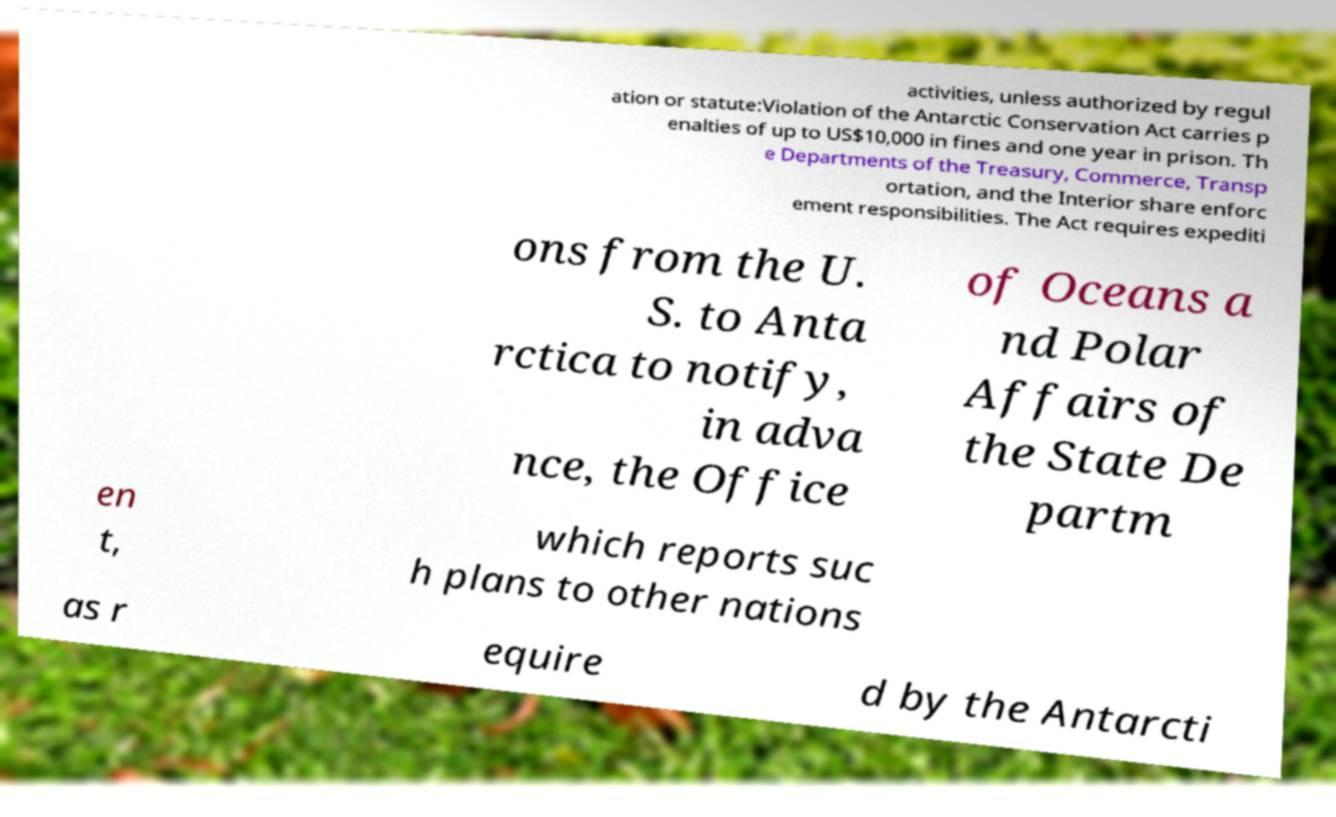For documentation purposes, I need the text within this image transcribed. Could you provide that? activities, unless authorized by regul ation or statute:Violation of the Antarctic Conservation Act carries p enalties of up to US$10,000 in fines and one year in prison. Th e Departments of the Treasury, Commerce, Transp ortation, and the Interior share enforc ement responsibilities. The Act requires expediti ons from the U. S. to Anta rctica to notify, in adva nce, the Office of Oceans a nd Polar Affairs of the State De partm en t, which reports suc h plans to other nations as r equire d by the Antarcti 